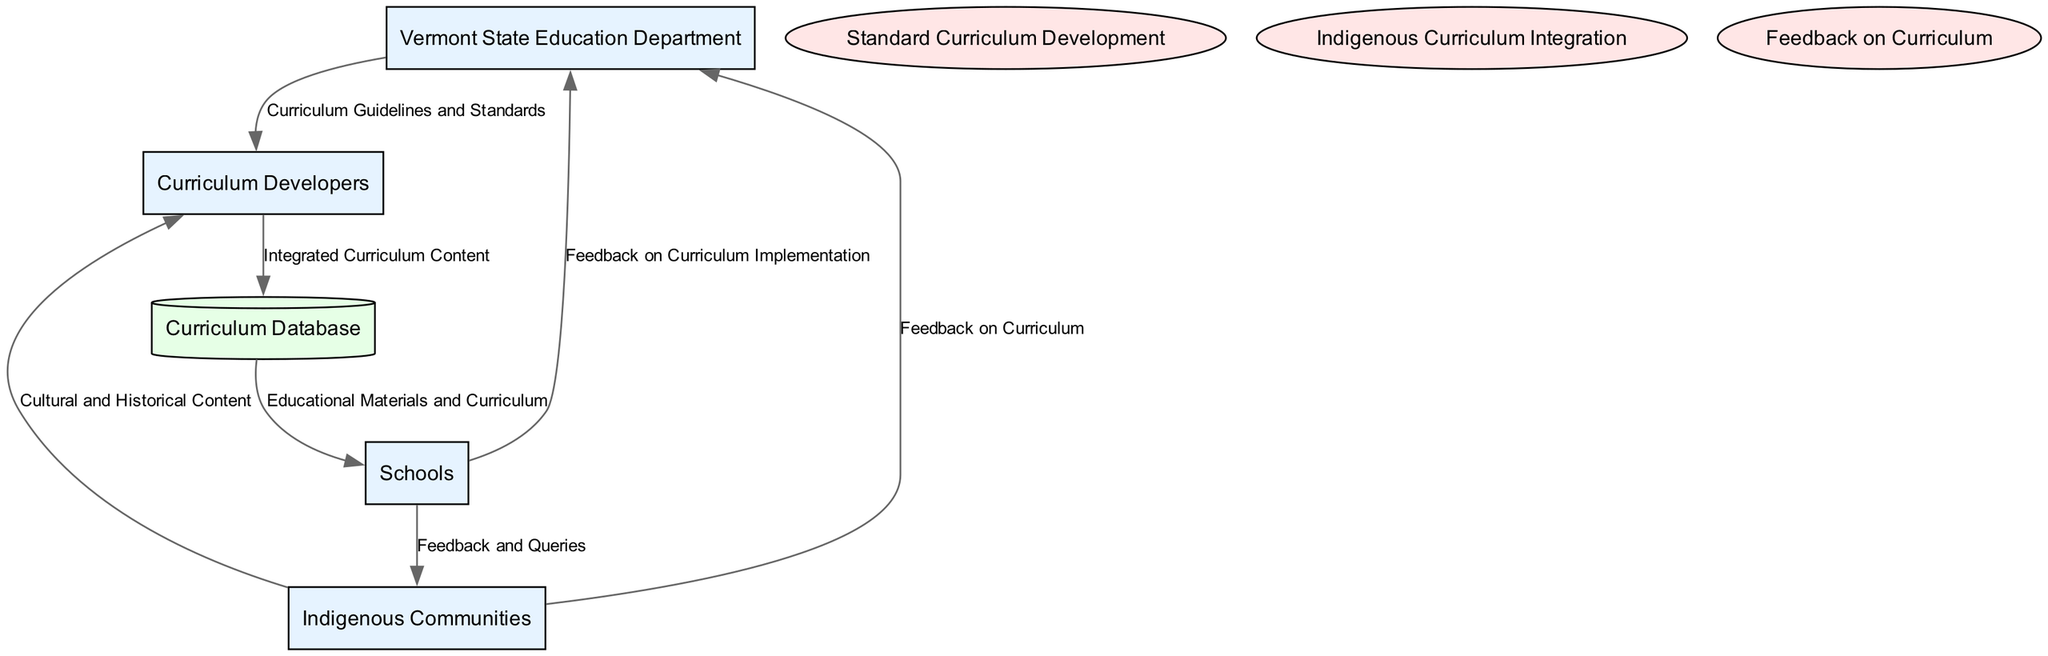What entities are involved in the diagram? The diagram includes four entities: Vermont State Education Department, Schools, Curriculum Developers, and Indigenous Communities.
Answer: Vermont State Education Department, Schools, Curriculum Developers, Indigenous Communities How many data flows are depicted in the diagram? There are six data flows illustrated in the diagram. Each flow represents a transfer of information between different entities or processes.
Answer: six Who provides "Cultural and Historical Content" to Curriculum Developers? The Indigenous Communities provide "Cultural and Historical Content" to Curriculum Developers, which is essential for curriculum integration.
Answer: Indigenous Communities What process specifically focuses on integrating indigenous content into the curriculum? The process called "Indigenous Curriculum Integration" is specifically designed for incorporating indigenous history and culture into the standard curriculum.
Answer: Indigenous Curriculum Integration Which entity receives "Educational Materials and Curriculum" from the Curriculum Database? Schools receive "Educational Materials and Curriculum" from the Curriculum Database, facilitating the educational process at the primary and secondary levels.
Answer: Schools What type of feedback does Schools send to the Vermont State Education Department? Schools provide "Feedback on Curriculum Implementation" to the Vermont State Education Department to inform about the curriculum's practical application and effectiveness.
Answer: Feedback on Curriculum Implementation Explain the flow of information from Indigenous Communities to Curriculum Developers. Indigenous Communities send "Cultural and Historical Content" to Curriculum Developers to ensure that indigenous perspectives and histories are included in the curriculum development process.
Answer: Cultural and Historical Content Which process collects feedback from both schools and indigenous communities? The process "Feedback on Curriculum" is responsible for collecting and implementing feedback from both schools and indigenous communities regarding the curriculum.
Answer: Feedback on Curriculum What role does the Curriculum Database play in the educational process? The Curriculum Database acts as a central repository that stores the "Integrated Curriculum Content," making it accessible to schools for educational purposes.
Answer: Central repository 